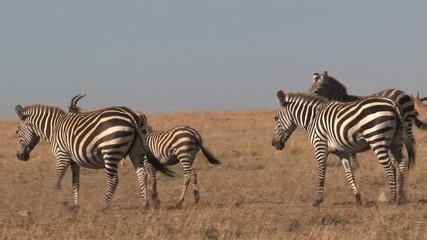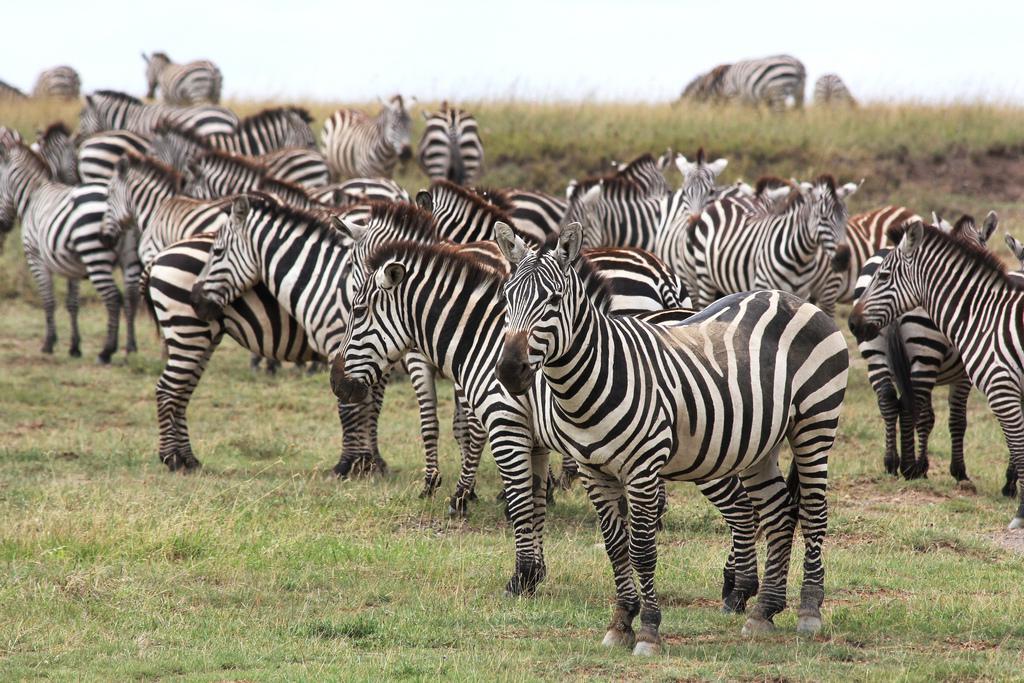The first image is the image on the left, the second image is the image on the right. Evaluate the accuracy of this statement regarding the images: "There are trees visible in both images.". Is it true? Answer yes or no. No. The first image is the image on the left, the second image is the image on the right. Analyze the images presented: Is the assertion "One image contains multiple rear-facing zebra in the foreground, and all images show only dry ground with no non-zebra animal herds visible." valid? Answer yes or no. Yes. 